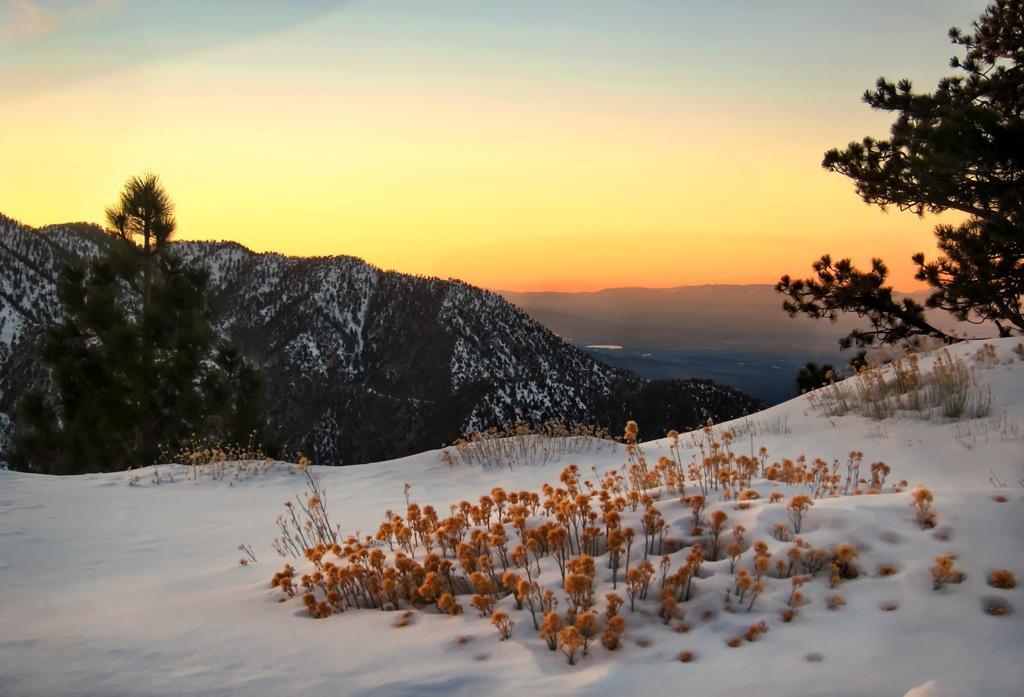Can you describe this image briefly? In this picture I can observe some snow on the land. I can observe some trees and hills. In the background there is sky. 